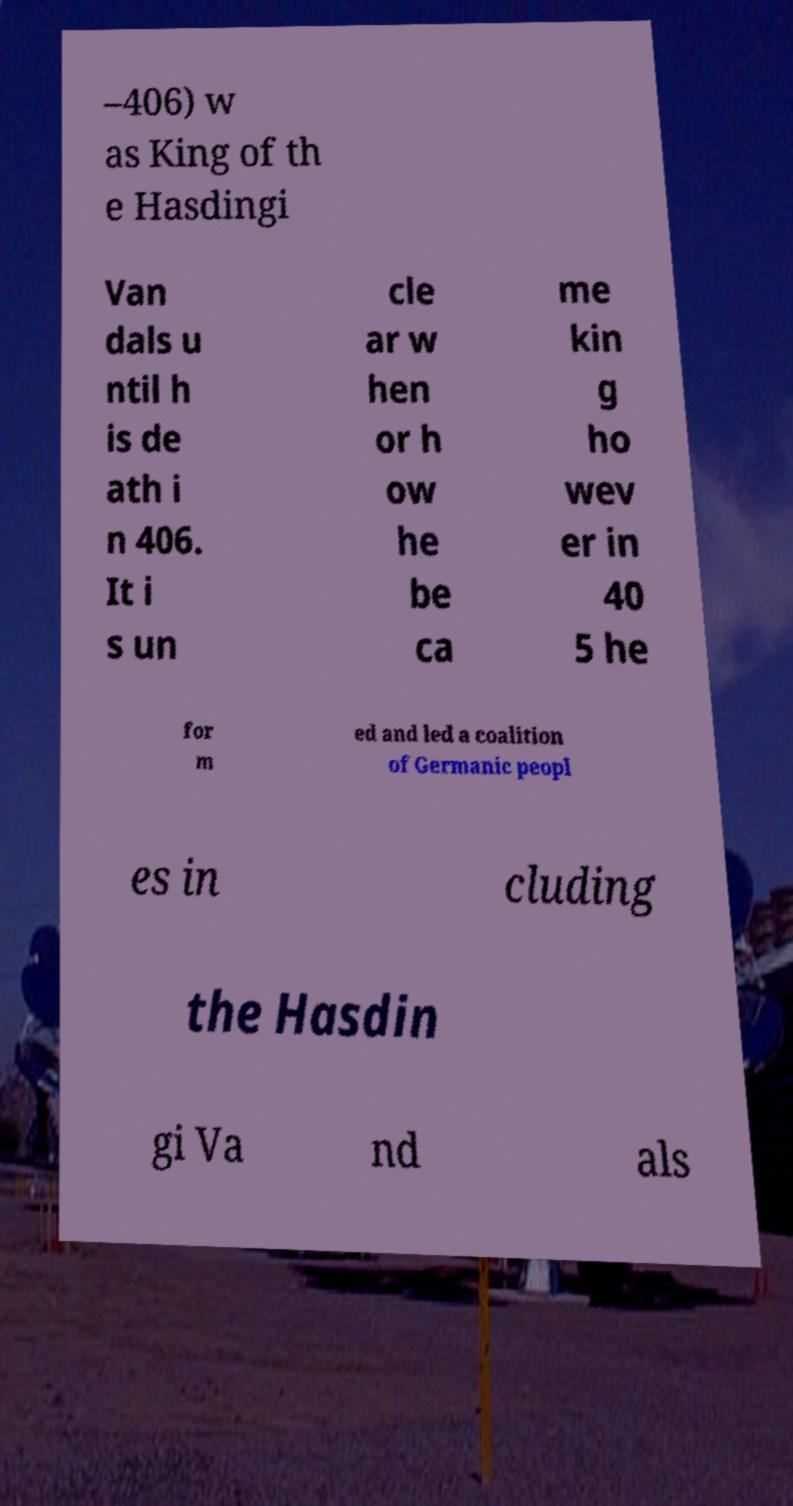For documentation purposes, I need the text within this image transcribed. Could you provide that? –406) w as King of th e Hasdingi Van dals u ntil h is de ath i n 406. It i s un cle ar w hen or h ow he be ca me kin g ho wev er in 40 5 he for m ed and led a coalition of Germanic peopl es in cluding the Hasdin gi Va nd als 